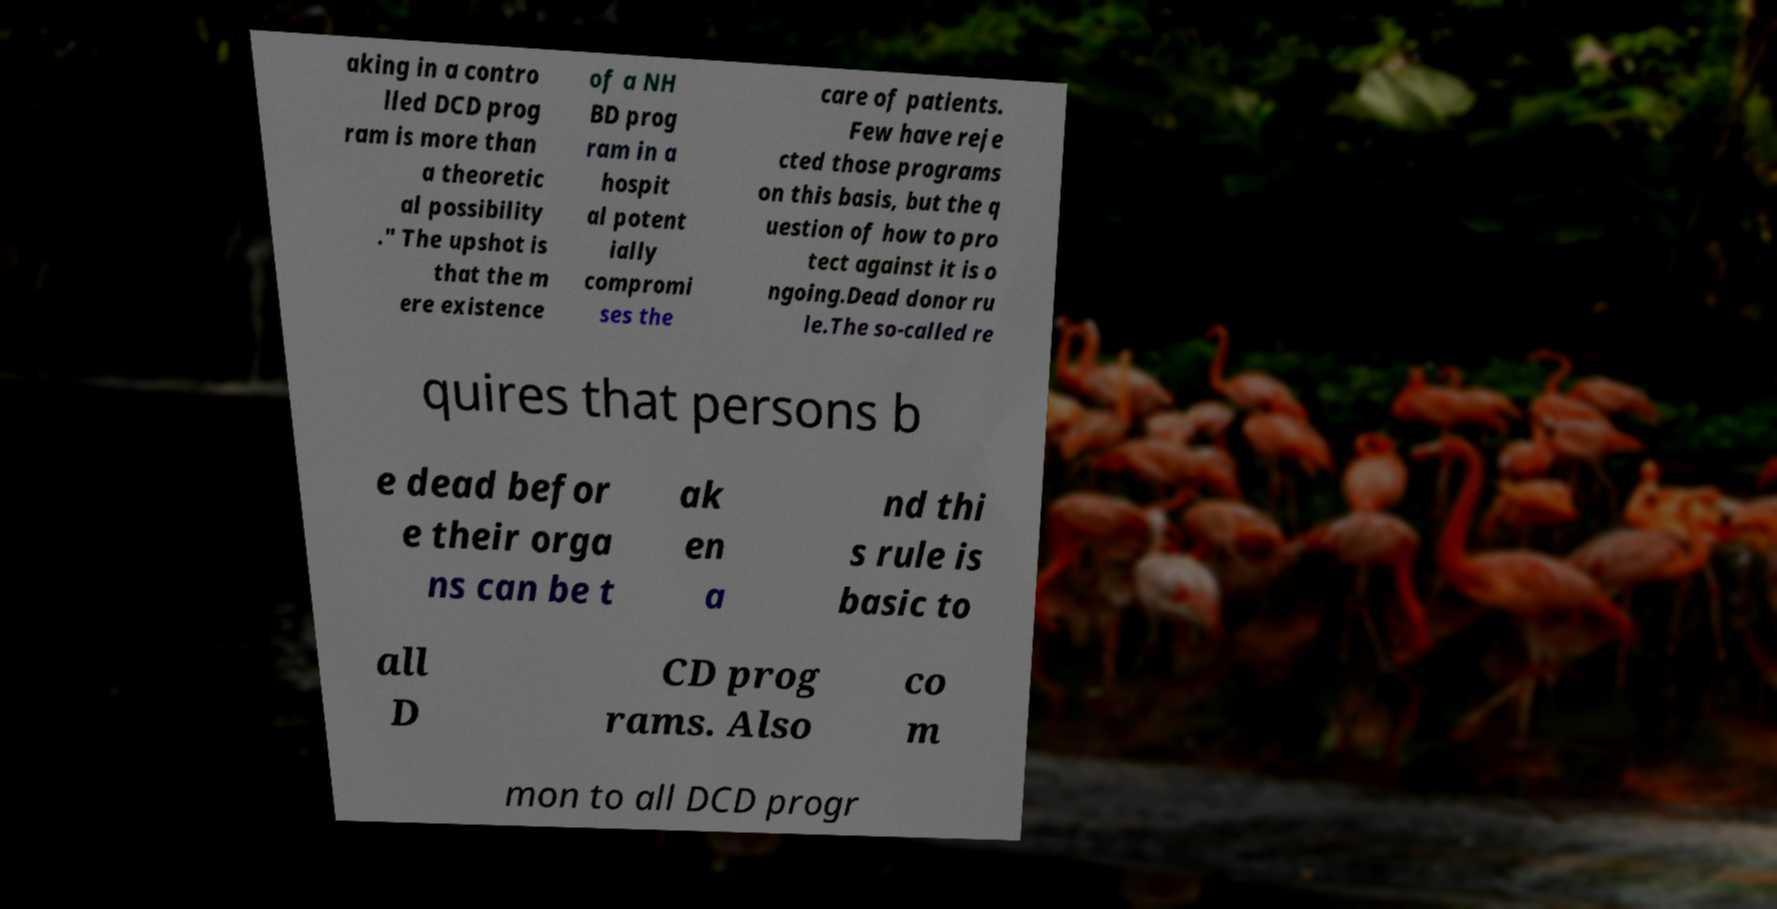What messages or text are displayed in this image? I need them in a readable, typed format. aking in a contro lled DCD prog ram is more than a theoretic al possibility ." The upshot is that the m ere existence of a NH BD prog ram in a hospit al potent ially compromi ses the care of patients. Few have reje cted those programs on this basis, but the q uestion of how to pro tect against it is o ngoing.Dead donor ru le.The so-called re quires that persons b e dead befor e their orga ns can be t ak en a nd thi s rule is basic to all D CD prog rams. Also co m mon to all DCD progr 